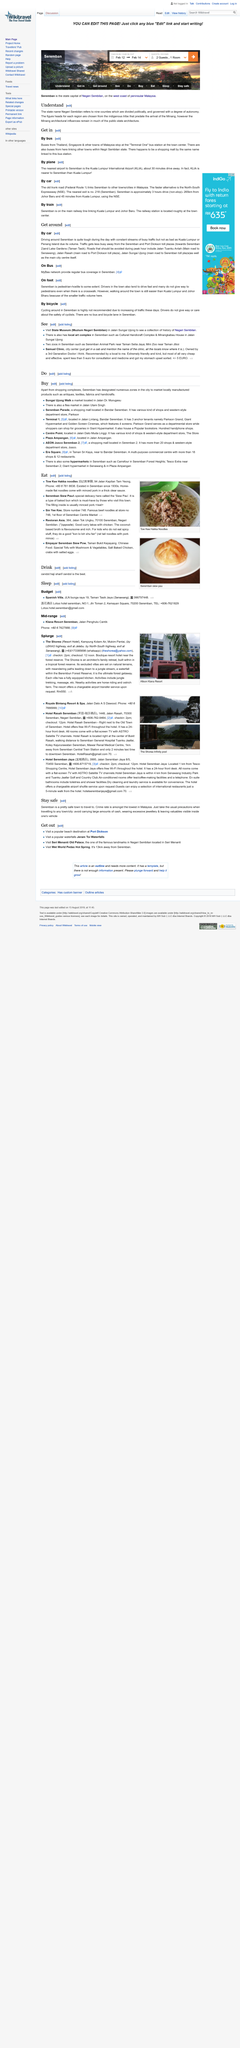List a handful of essential elements in this visual. Negri Sembilan is comprised of nine counties. Yes, there is a shopping mall linked to the Terminal One bus station, providing convenient access to a range of shopping and dining options for passengers. Yes, you can get into the state of Negri Sembilan by bus. 